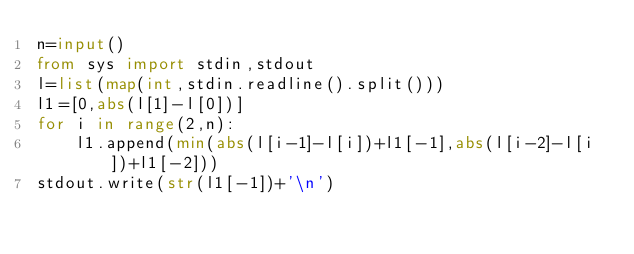<code> <loc_0><loc_0><loc_500><loc_500><_Python_>n=input()
from sys import stdin,stdout
l=list(map(int,stdin.readline().split()))
l1=[0,abs(l[1]-l[0])]
for i in range(2,n):
    l1.append(min(abs(l[i-1]-l[i])+l1[-1],abs(l[i-2]-l[i])+l1[-2]))
stdout.write(str(l1[-1])+'\n')
    
</code> 